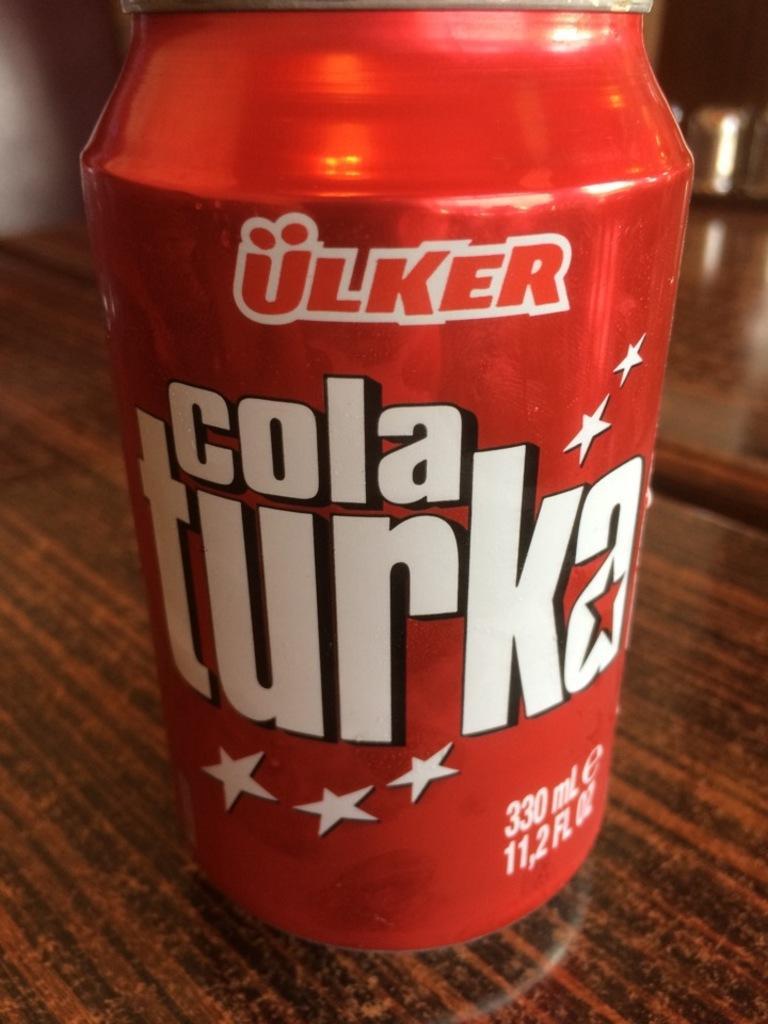In one or two sentences, can you explain what this image depicts? In this image there are wooden objects that looks like a table, there is an object on the table, there is a red color can on the table, there is text on the can, there are stars on the can, there are numbers on the can. 